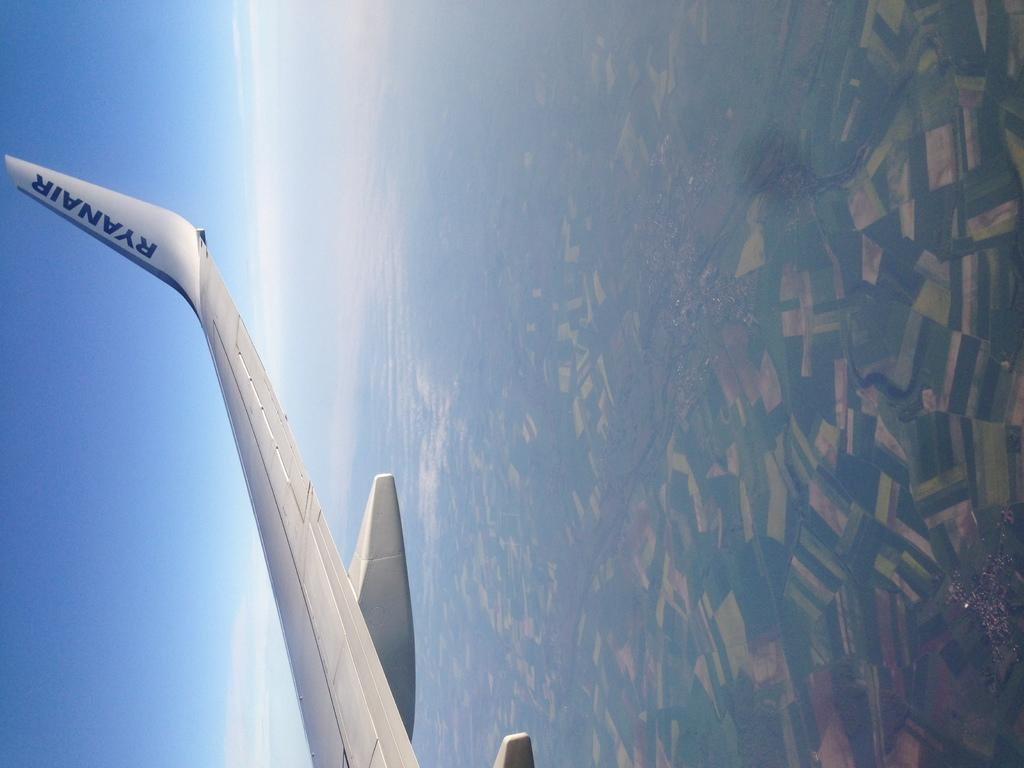<image>
Provide a brief description of the given image. Ryanair wrote in blue on a white airplane in the sky 